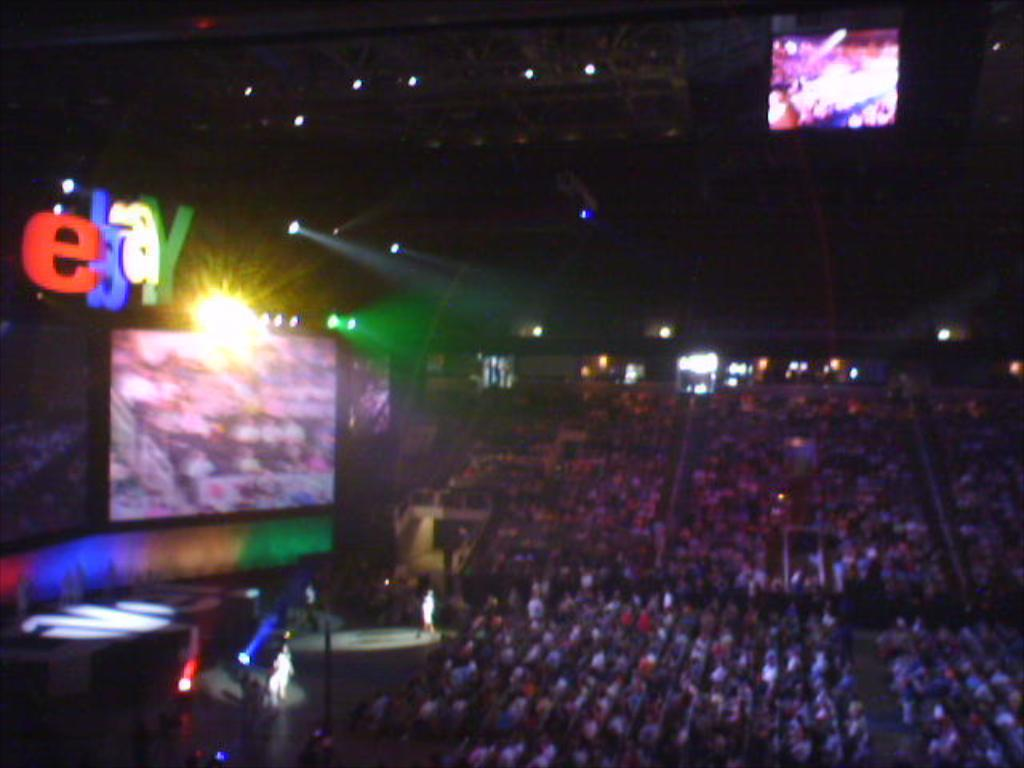<image>
Render a clear and concise summary of the photo. an ebay sign that is above the arena 